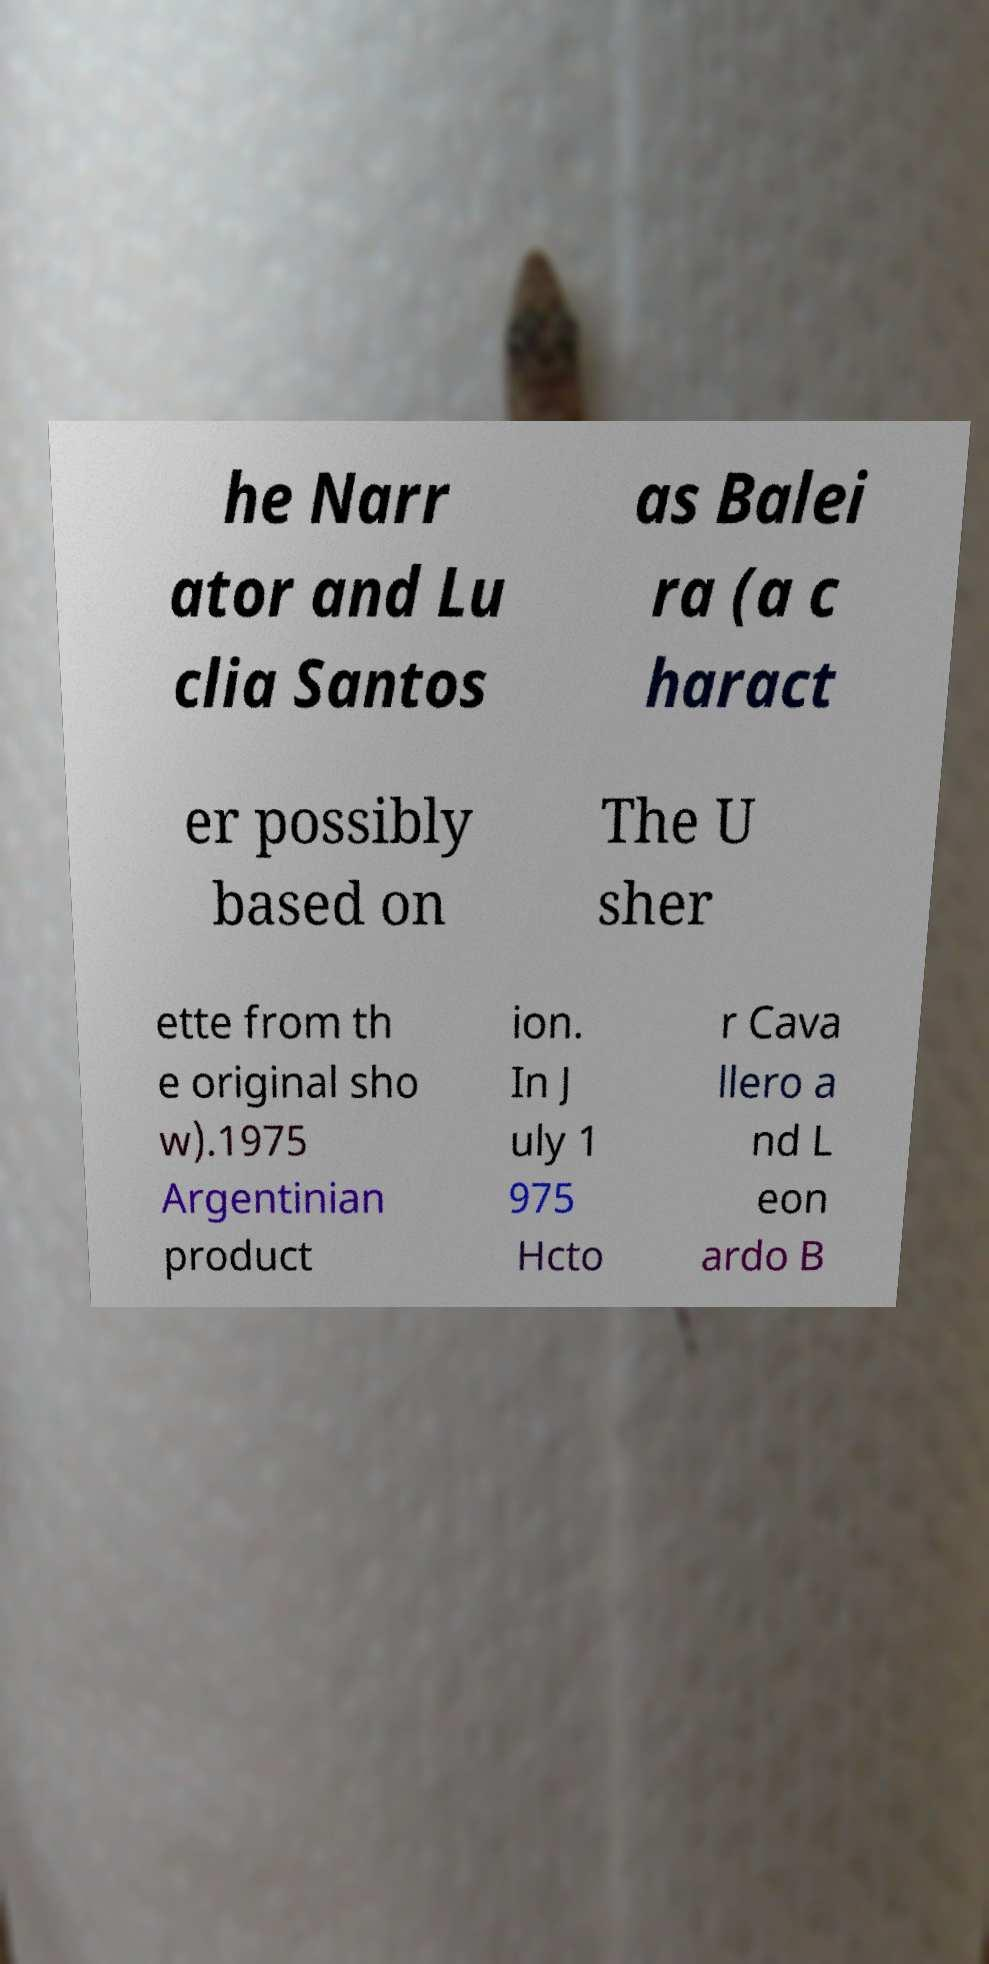Please identify and transcribe the text found in this image. he Narr ator and Lu clia Santos as Balei ra (a c haract er possibly based on The U sher ette from th e original sho w).1975 Argentinian product ion. In J uly 1 975 Hcto r Cava llero a nd L eon ardo B 